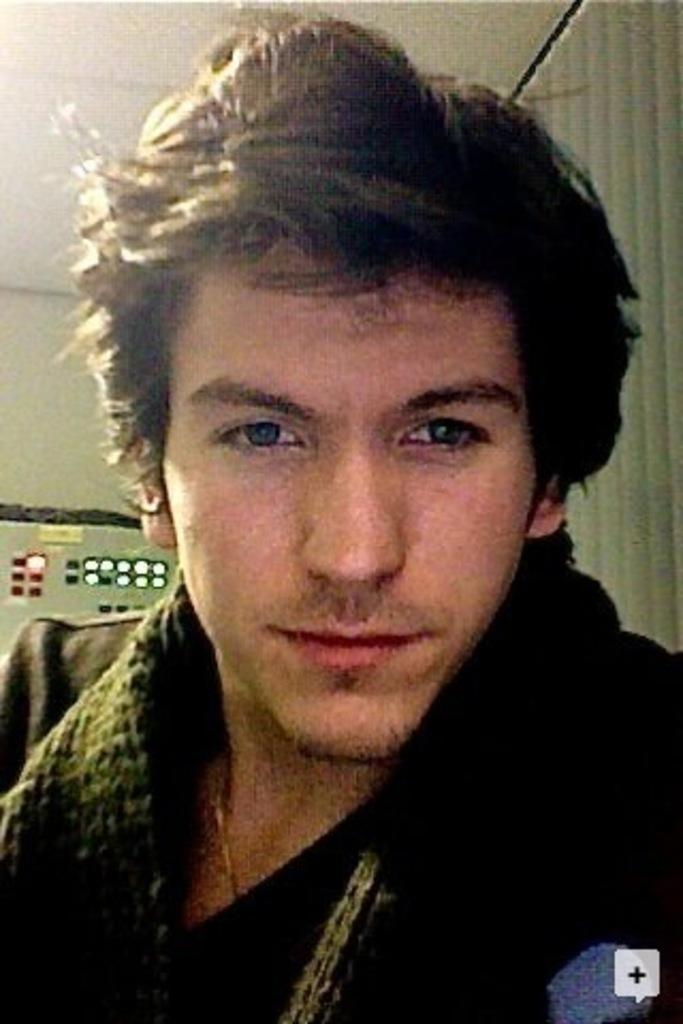Who or what is present in the image? There is a person in the image. What is the person wearing? The person is wearing a black shirt. What can be seen in the background of the image? There are lights visible in the background of the image. What type of window covering is present in the image? There is a window blind in the image. What type of zinc object is visible on the person's head in the image? There is no zinc object visible on the person's head in the image. What is inside the jar that is present in the image? There is no jar present in the image. 